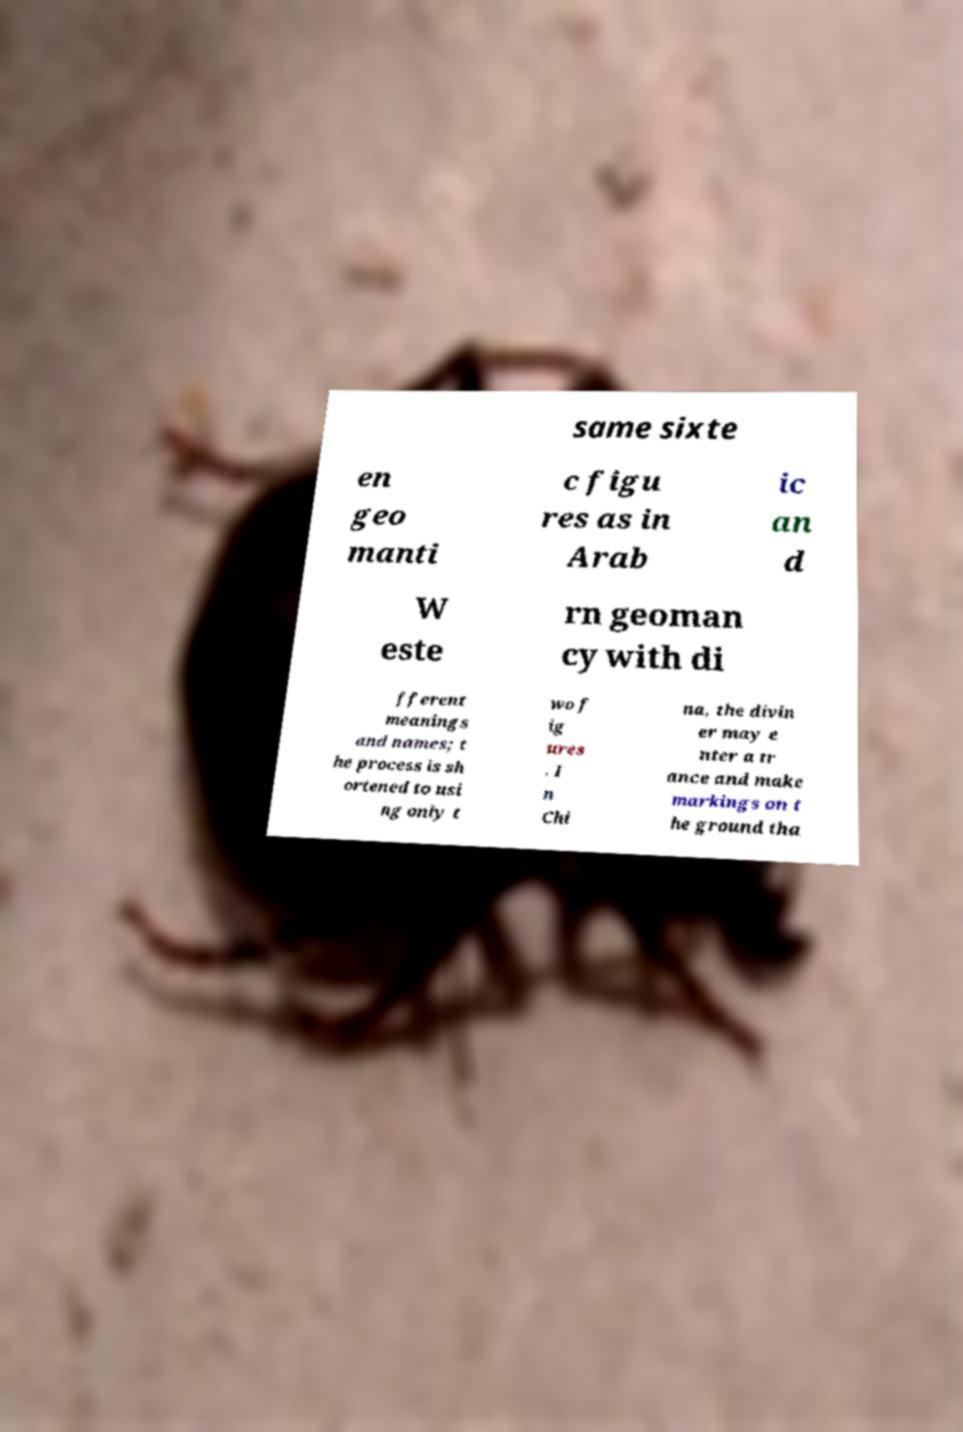Could you assist in decoding the text presented in this image and type it out clearly? same sixte en geo manti c figu res as in Arab ic an d W este rn geoman cy with di fferent meanings and names; t he process is sh ortened to usi ng only t wo f ig ures . I n Chi na, the divin er may e nter a tr ance and make markings on t he ground tha 